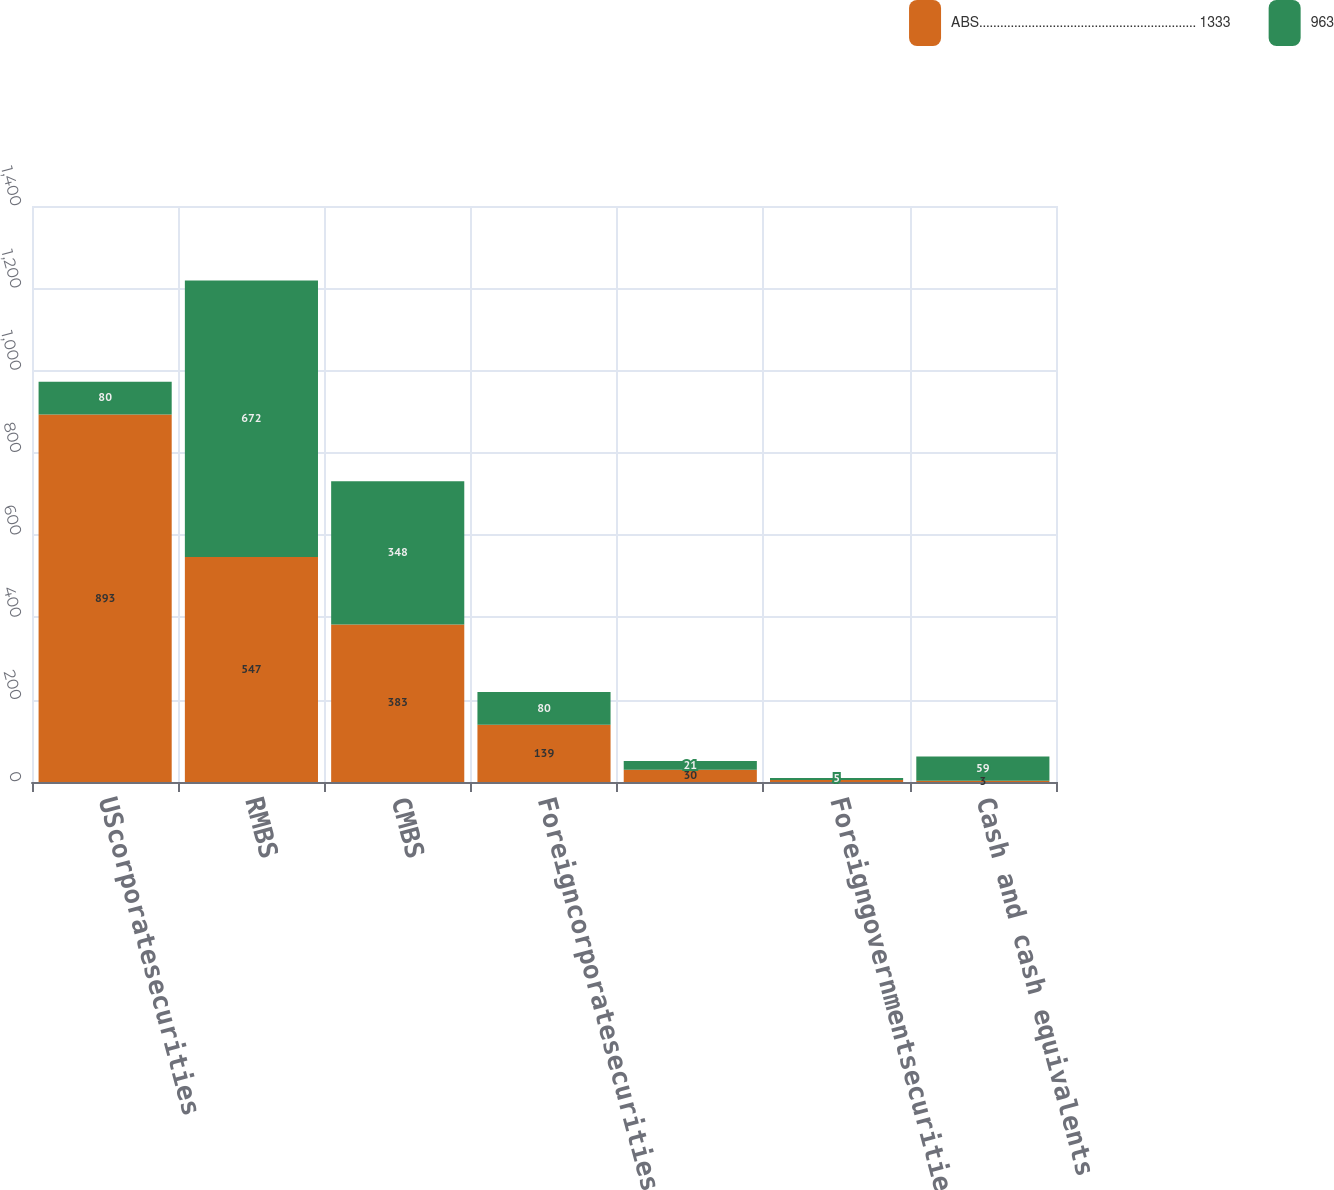Convert chart. <chart><loc_0><loc_0><loc_500><loc_500><stacked_bar_chart><ecel><fcel>UScorporatesecurities<fcel>RMBS<fcel>CMBS<fcel>Foreigncorporatesecurities<fcel>Unnamed: 5<fcel>Foreigngovernmentsecurities<fcel>Cash and cash equivalents<nl><fcel>ABS.............................................................. 1333<fcel>893<fcel>547<fcel>383<fcel>139<fcel>30<fcel>5<fcel>3<nl><fcel>963<fcel>80<fcel>672<fcel>348<fcel>80<fcel>21<fcel>5<fcel>59<nl></chart> 